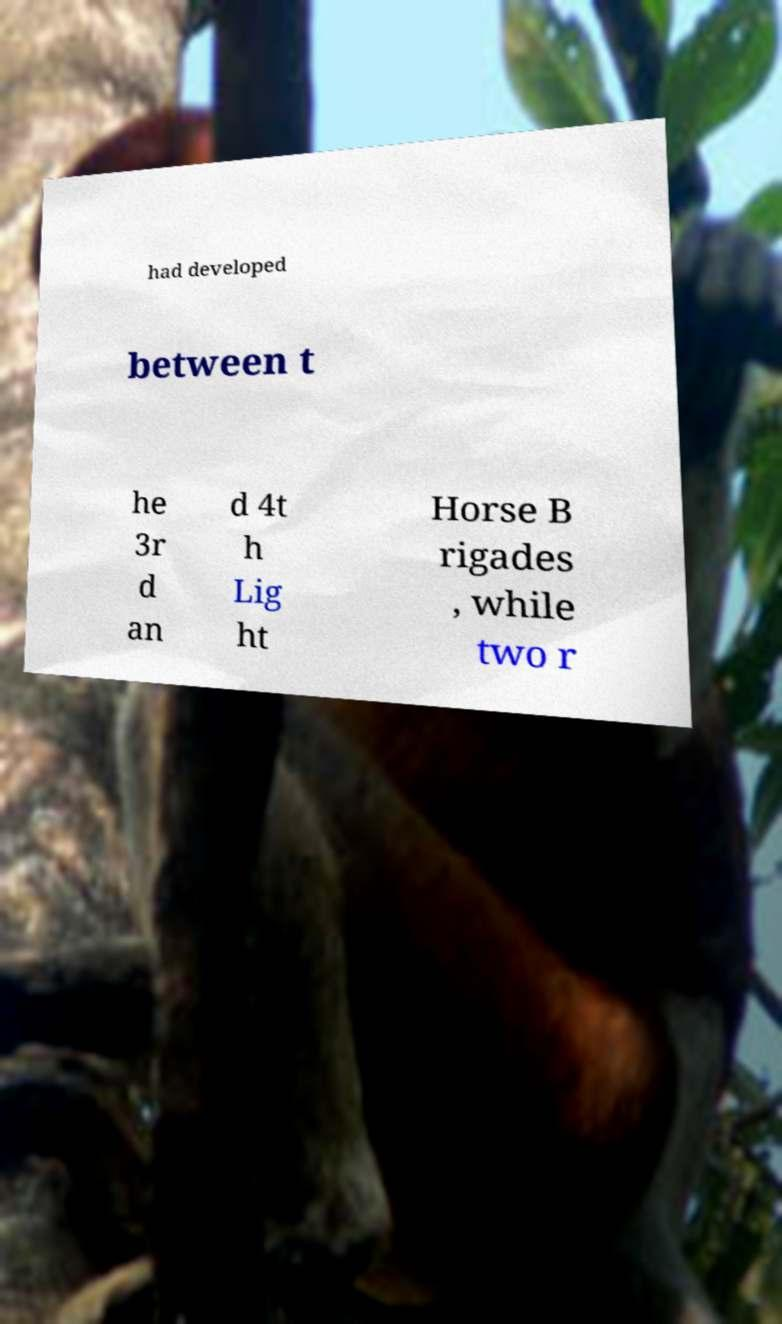Could you assist in decoding the text presented in this image and type it out clearly? had developed between t he 3r d an d 4t h Lig ht Horse B rigades , while two r 